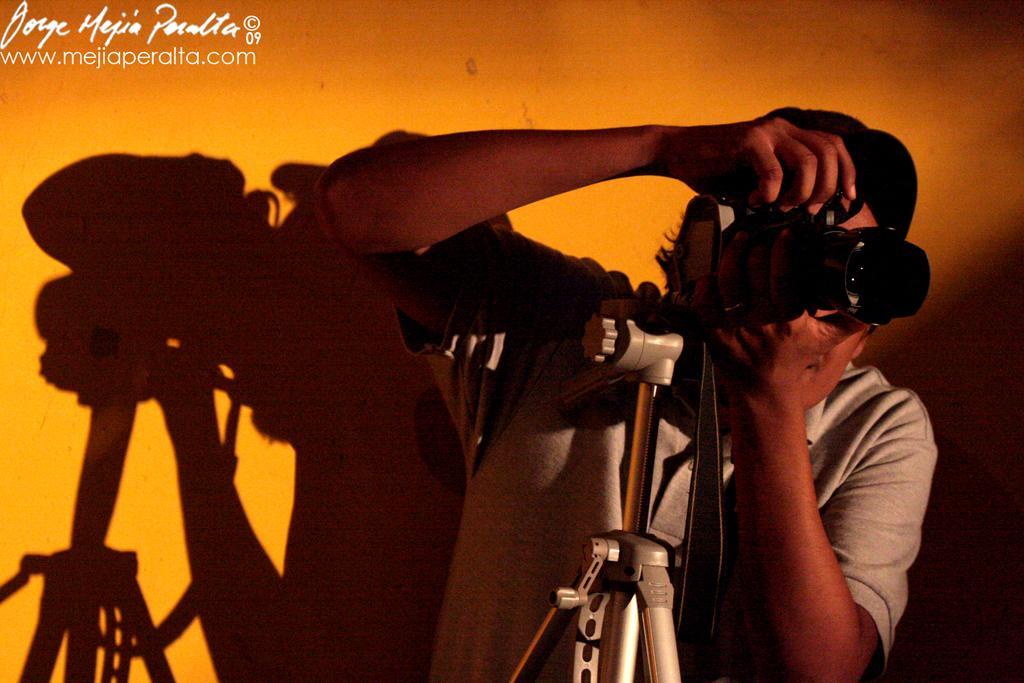Could you give a brief overview of what you see in this image? In this image we can see a person holding camera in his hands. In addition to this we can see the tripod and walls. 